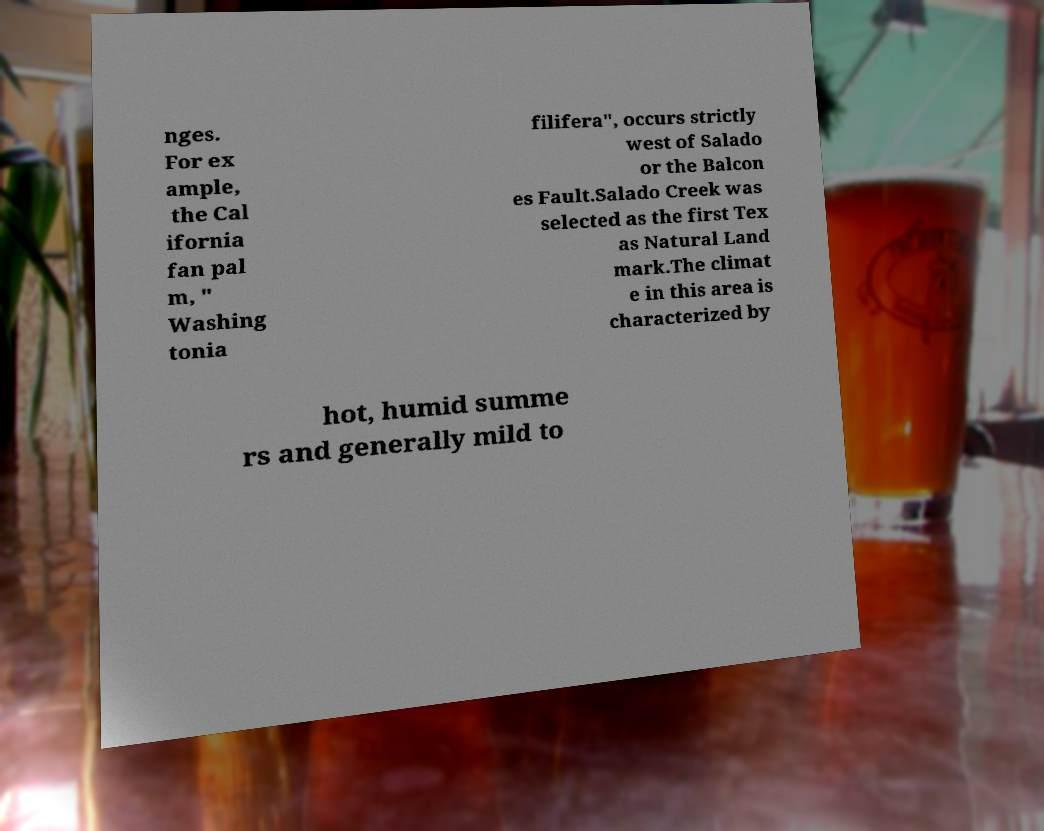Can you read and provide the text displayed in the image?This photo seems to have some interesting text. Can you extract and type it out for me? nges. For ex ample, the Cal ifornia fan pal m, " Washing tonia filifera", occurs strictly west of Salado or the Balcon es Fault.Salado Creek was selected as the first Tex as Natural Land mark.The climat e in this area is characterized by hot, humid summe rs and generally mild to 